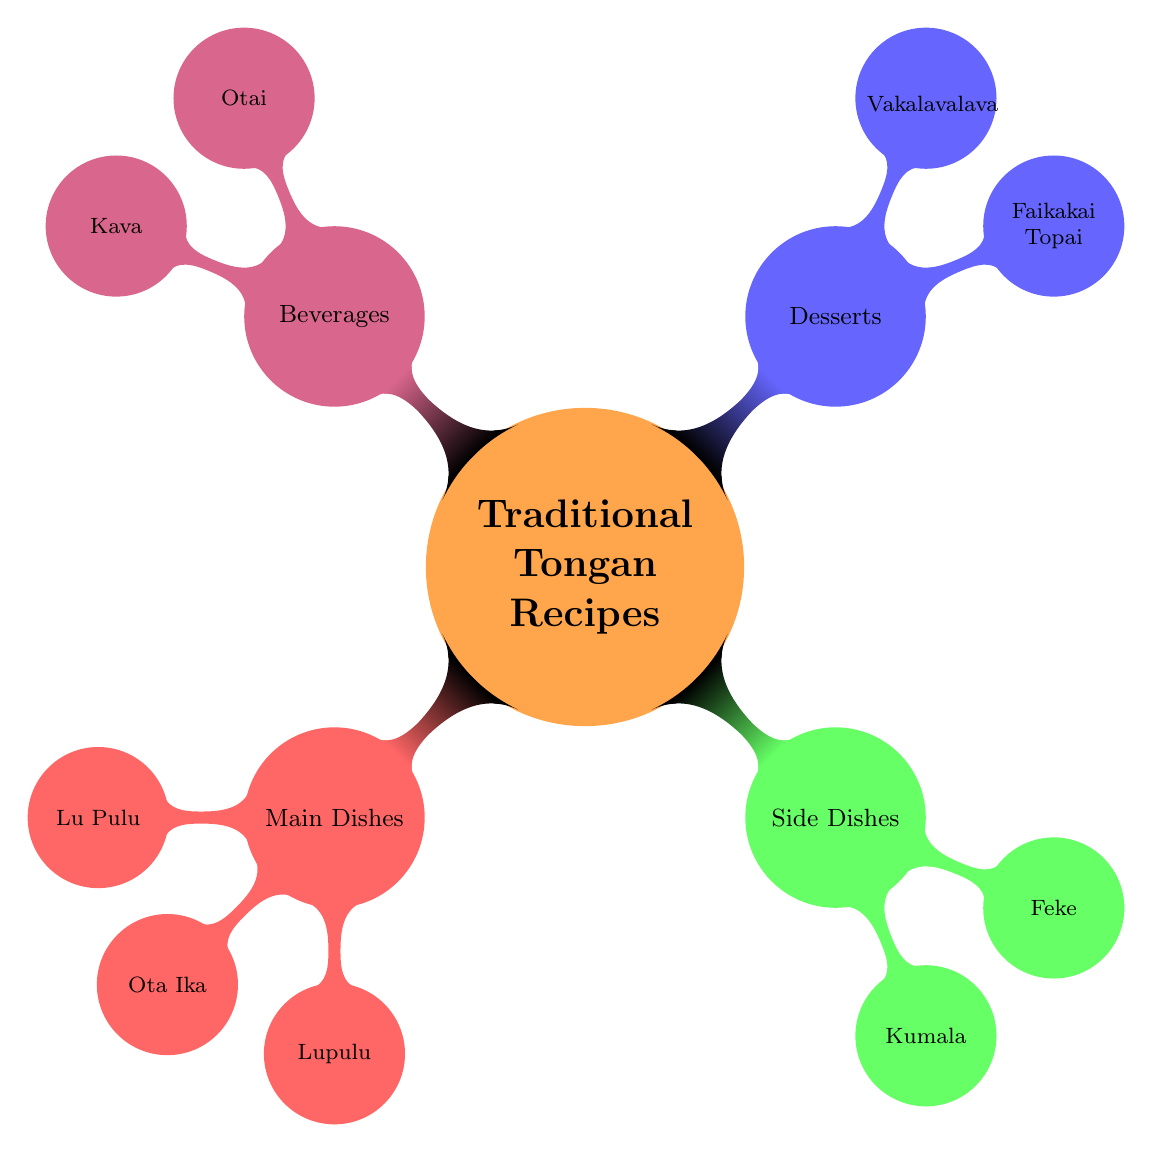What are the four main categories in the Traditional Tongan Recipes Collection? The diagram identifies four main categories: Main Dishes, Side Dishes, Desserts, and Beverages.
Answer: Main Dishes, Side Dishes, Desserts, Beverages How many desserts are listed in the diagram? There are two desserts shown in the Desserts category: Faikakai Topai and Vakalavalava.
Answer: 2 Which ingredient is common to both Lu Pulu and Lupulu? Lu Pulu and Lupulu both use coconut cream as a common ingredient.
Answer: Coconut Cream What is the cooking method for Ota Ika? The diagram specifies that Ota Ika is marinated in lemon juice and mixed with chopped vegetables and coconut cream.
Answer: Marinated in lemon juice and mixed with chopped vegetables and coconut cream What type of dish is Kumala? Kumala is classified as a Side Dish in the Traditional Tongan Recipes Collection.
Answer: Side Dish Which beverage is made from Kava Root? The diagram indicates that Kava is the beverage made from Kava Root.
Answer: Kava How many main dishes are featured in the diagram? There are three main dishes shown: Lu Pulu, Ota Ika, and Lupulu, totaling three dishes.
Answer: 3 What ingredient is used in both Faikakai Topai and Vakalavalava? The common ingredient is coconut milk, present in both desserts.
Answer: Coconut Milk What is the preparation method for Otai? The diagram states that Otai is mixed together to create a refreshing fruit drink.
Answer: Mixed together to make a refreshing fruit drink 